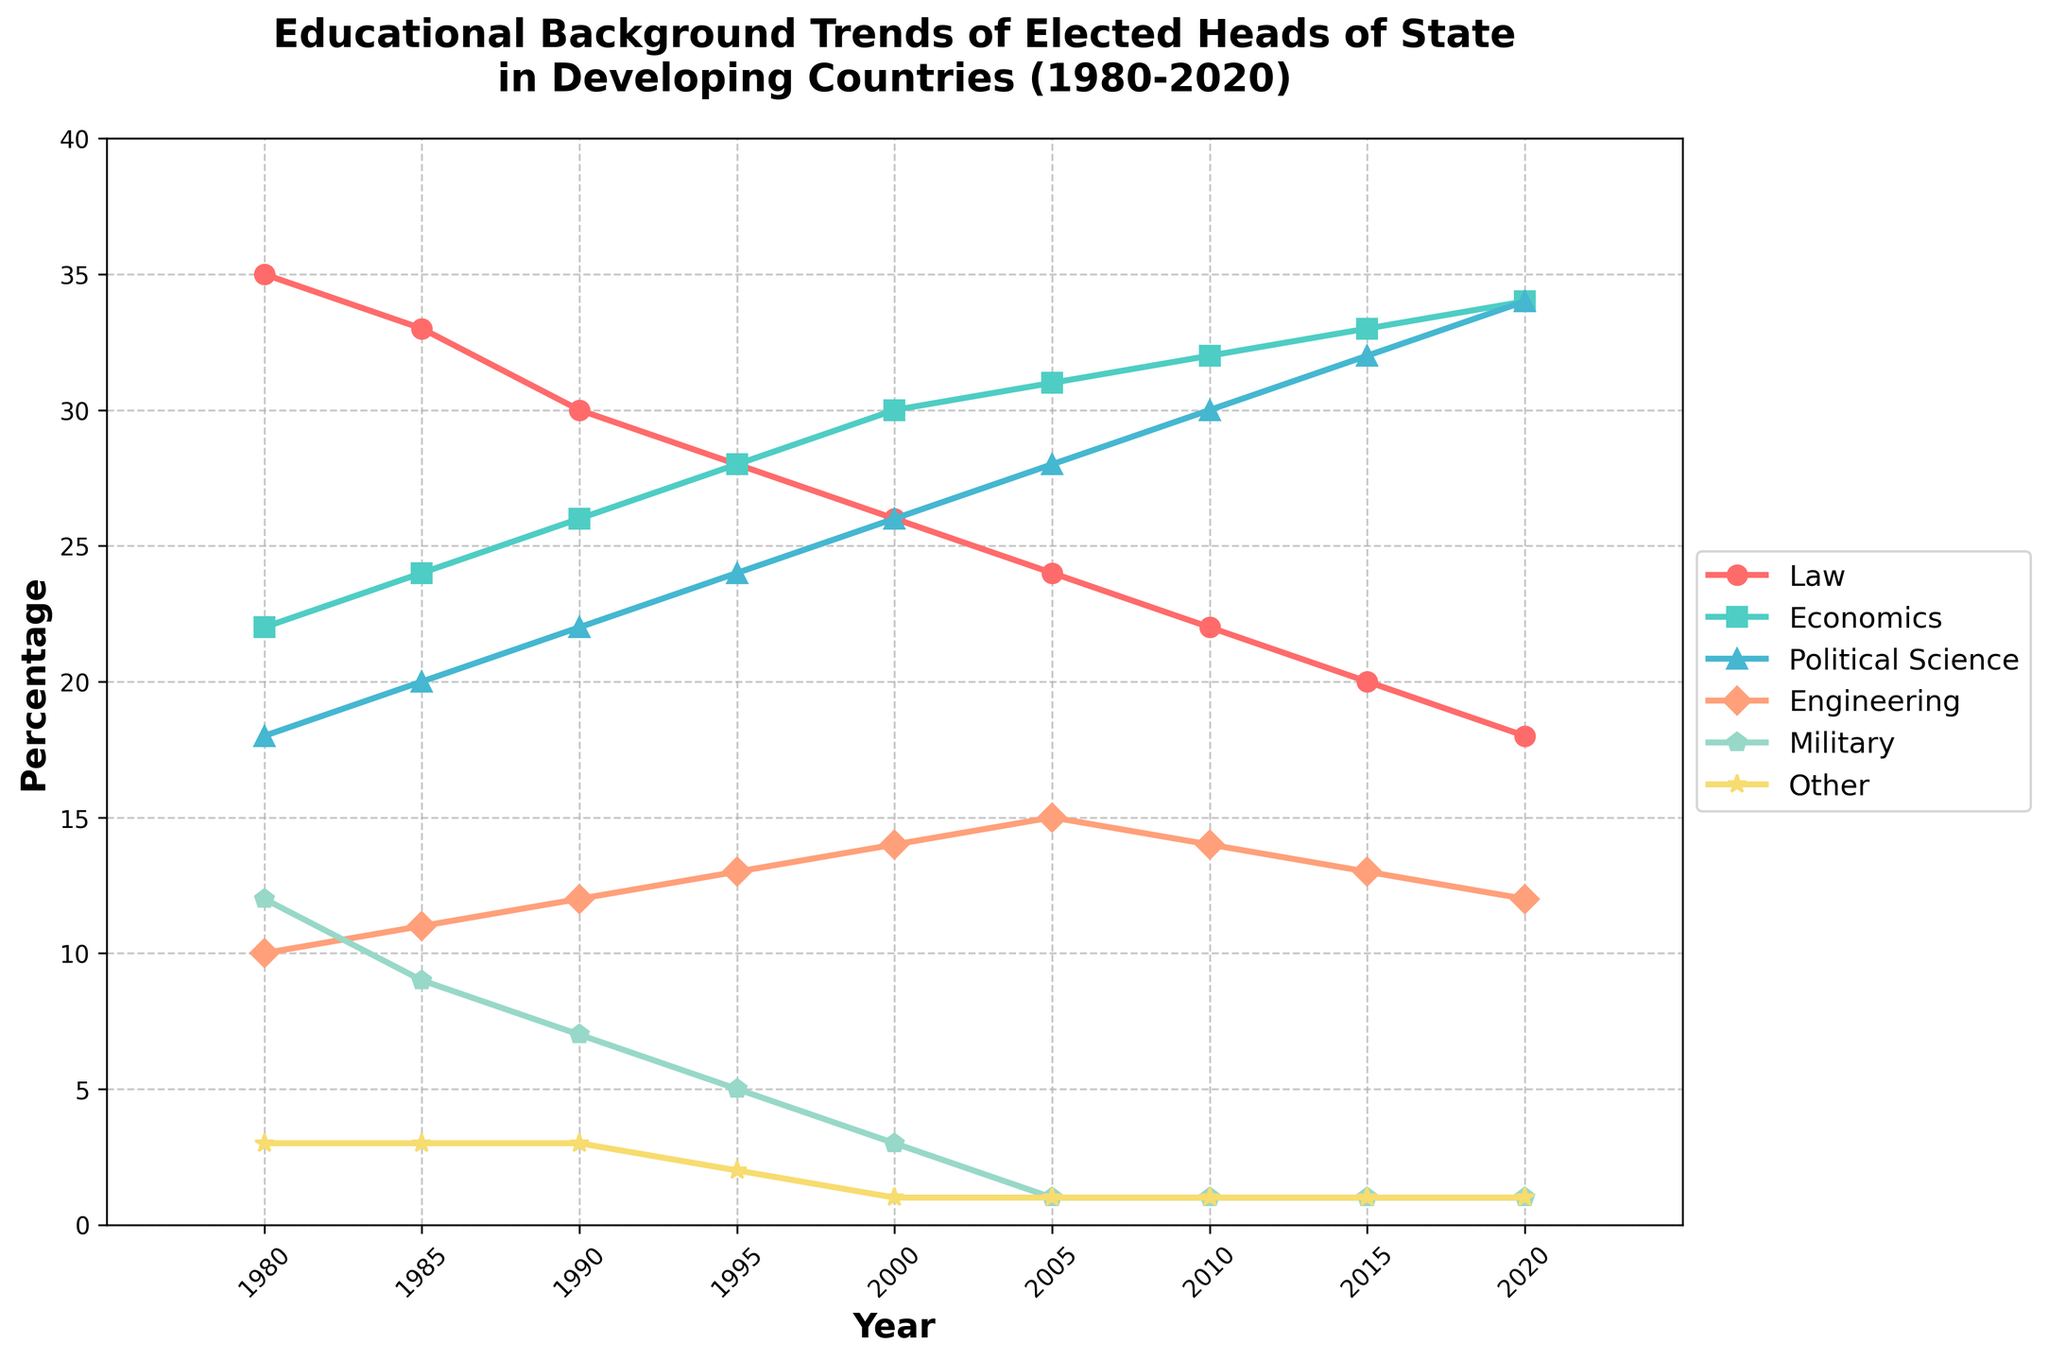What trend do you see in the percentage of heads of state with a background in Law from 1980 to 2020? The percentage of heads of state with a background in Law decreased consistently from 35% in 1980 to 18% in 2020.
Answer: Decreasing trend Which educational background has shown the most consistent increase over the years? The background in Economics showed the most consistent increase, from 22% in 1980 to 34% in 2020.
Answer: Economics By how many percentage points did the representation of heads of state with a Political Science background increase from 1980 to 2020? The percentage increased from 18% in 1980 to 34% in 2020. The difference is 34 - 18 = 16 percentage points.
Answer: 16 In which year did Engineering backgrounds among heads of state reach their peak representation? Engineering backgrounds reached their peak in 2005 with 15%.
Answer: 2005 Compare the percentages of heads of state with Military backgrounds in 1980 and 2020. Which year had more representation, and by how much? In 1980, Military backgrounds accounted for 12%, whereas in 2020, it was 1%. 1980 had more representation by 12% - 1% = 11 percentage points.
Answer: 1980 by 11 percentage points What is the average percentage of heads of state with backgrounds in Political Science from 1980 to 2020? The percentages over the years are 18, 20, 22, 24, 26, 28, 30, 32, and 34. The average is (18+20+22+24+26+28+30+32+34)/9 = 26%.
Answer: 26% Which category showed the largest decrease in representation from 1980 to 2020, and what was the difference in percentage points? The Law background showed the largest decrease from 35% in 1980 to 18% in 2020, a difference of 35 - 18 = 17 percentage points.
Answer: Law, 17 percentage points Was there any category whose representation remained constant over the years? The category 'Other' remained constant at 3% initially but reduced to 1% in later years, so there are no categories with entirely constant representation.
Answer: No Looking at the colors of the lines, which color represents the category with the highest representation in 2020? The green color represents Economics, which has the highest representation of 34% in 2020.
Answer: Green 